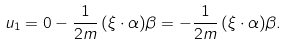Convert formula to latex. <formula><loc_0><loc_0><loc_500><loc_500>u _ { 1 } & = 0 - \frac { 1 } { 2 m } \, ( \xi \cdot \alpha ) \beta = - \frac { 1 } { 2 m } \, ( \xi \cdot \alpha ) \beta .</formula> 